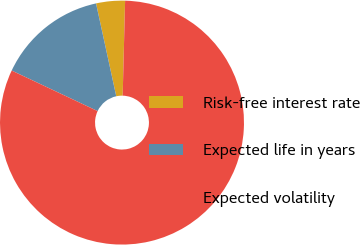<chart> <loc_0><loc_0><loc_500><loc_500><pie_chart><fcel>Risk-free interest rate<fcel>Expected life in years<fcel>Expected volatility<nl><fcel>3.82%<fcel>14.57%<fcel>81.61%<nl></chart> 